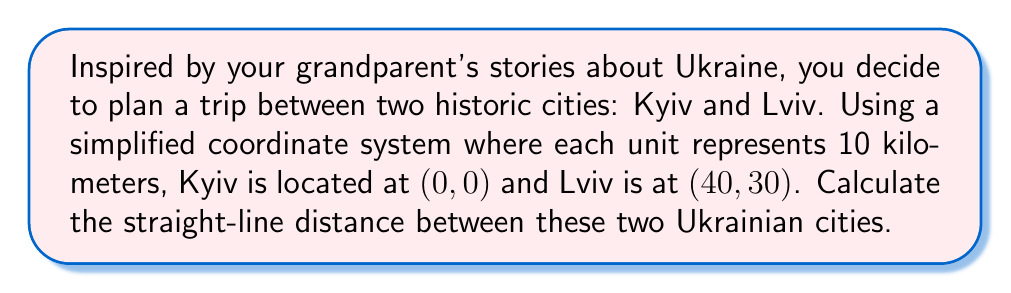Teach me how to tackle this problem. To solve this problem, we can use the distance formula derived from the Pythagorean theorem. The distance formula for two points $(x_1, y_1)$ and $(x_2, y_2)$ is:

$$d = \sqrt{(x_2 - x_1)^2 + (y_2 - y_1)^2}$$

Let's identify our points:
- Kyiv: $(x_1, y_1) = (0, 0)$
- Lviv: $(x_2, y_2) = (40, 30)$

Now, let's substitute these values into the formula:

$$\begin{align*}
d &= \sqrt{(40 - 0)^2 + (30 - 0)^2} \\
&= \sqrt{40^2 + 30^2} \\
&= \sqrt{1600 + 900} \\
&= \sqrt{2500} \\
&= 50
\end{align*}$$

Since each unit represents 10 kilometers, we need to multiply our result by 10:

$$50 \times 10 = 500\text{ km}$$

[asy]
unitsize(4mm);
draw((-5,-5)--(45,35),gray);
draw((-5,0)--(45,0),gray);
draw((0,-5)--(0,35),gray);
dot((0,0));
dot((40,30));
label("Kyiv (0,0)", (0,0), SW);
label("Lviv (40,30)", (40,30), NE);
draw((0,0)--(40,30),red,Arrow);
label("500 km", (20,15), NW, red);
[/asy]
Answer: The straight-line distance between Kyiv and Lviv is 500 kilometers. 